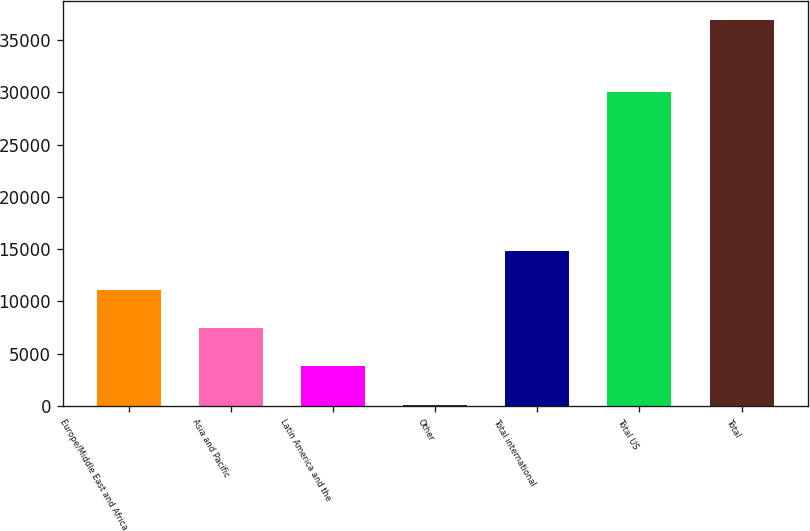Convert chart. <chart><loc_0><loc_0><loc_500><loc_500><bar_chart><fcel>Europe/Middle East and Africa<fcel>Asia and Pacific<fcel>Latin America and the<fcel>Other<fcel>Total international<fcel>Total US<fcel>Total<nl><fcel>11124.8<fcel>7442.2<fcel>3759.6<fcel>77<fcel>14807.4<fcel>30014<fcel>36903<nl></chart> 